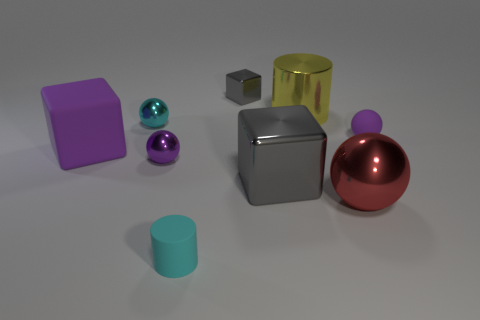The rubber thing that is both right of the cyan shiny object and to the left of the red sphere is what color?
Your answer should be compact. Cyan. Is there anything else that is the same color as the large metallic sphere?
Your answer should be very brief. No. What color is the shiny cube that is in front of the small matte object on the right side of the big red metallic ball?
Give a very brief answer. Gray. Is the red thing the same size as the cyan rubber object?
Your answer should be compact. No. Does the cyan object behind the large metallic ball have the same material as the gray thing that is in front of the small gray block?
Your answer should be very brief. Yes. The matte object that is on the left side of the rubber object that is in front of the big block that is on the right side of the tiny cyan cylinder is what shape?
Provide a succinct answer. Cube. Are there more yellow objects than blue rubber things?
Your response must be concise. Yes. Is there a big blue cylinder?
Your answer should be compact. No. What number of things are either metallic spheres to the left of the red shiny thing or purple matte things that are to the left of the yellow cylinder?
Offer a very short reply. 3. Is the color of the tiny metal cube the same as the big metal cube?
Offer a very short reply. Yes. 